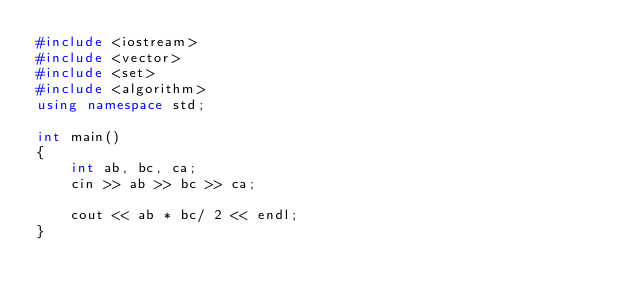Convert code to text. <code><loc_0><loc_0><loc_500><loc_500><_C++_>#include <iostream>
#include <vector>
#include <set>
#include <algorithm>
using namespace std;

int main()
{
    int ab, bc, ca;
    cin >> ab >> bc >> ca;

    cout << ab * bc/ 2 << endl;   
}</code> 